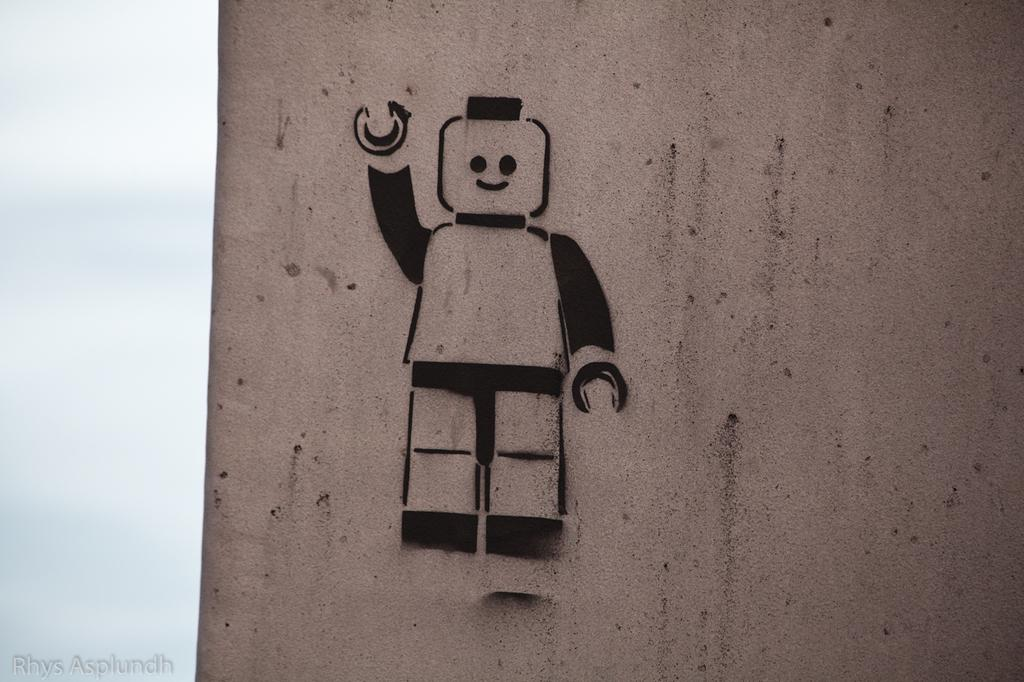What is depicted on the wall in the image? There is a sketch in the shape of a robot on a wall. What is the weather like in the image? The sky is cloudy in the image. What type of wax is being used by the writer in the image? There is no writer or wax present in the image; it only features a sketch of a robot on a wall and a cloudy sky. 